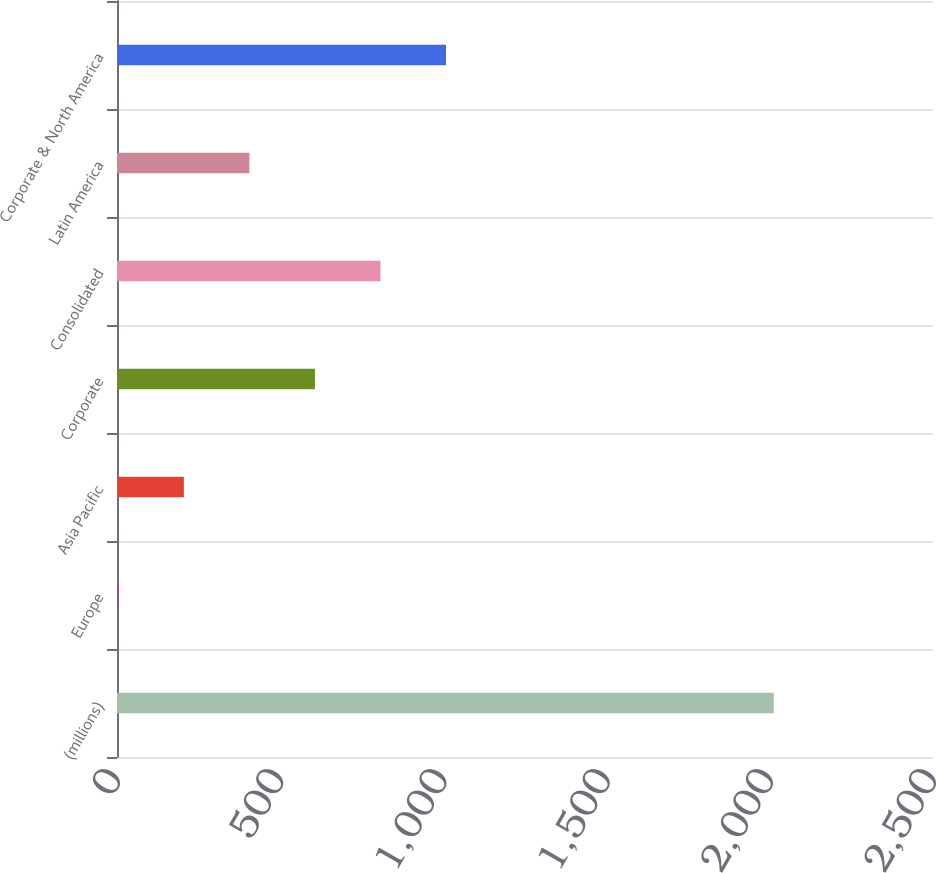Convert chart. <chart><loc_0><loc_0><loc_500><loc_500><bar_chart><fcel>(millions)<fcel>Europe<fcel>Asia Pacific<fcel>Corporate<fcel>Consolidated<fcel>Latin America<fcel>Corporate & North America<nl><fcel>2012<fcel>4<fcel>204.8<fcel>606.4<fcel>807.2<fcel>405.6<fcel>1008<nl></chart> 